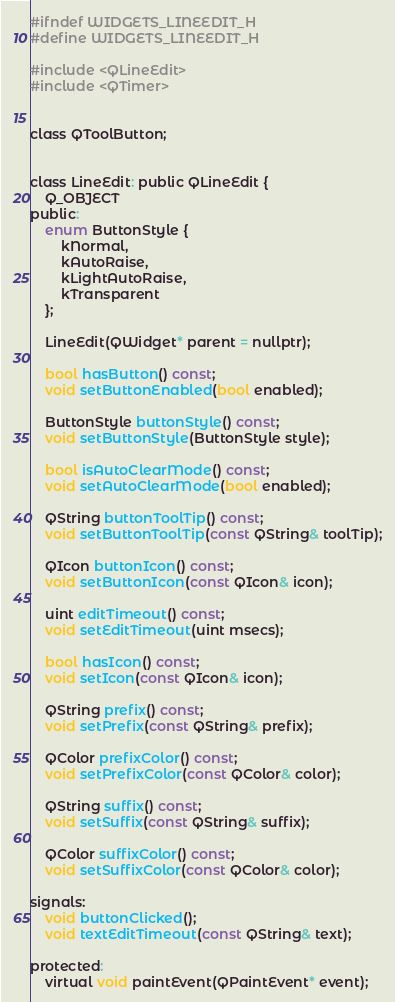Convert code to text. <code><loc_0><loc_0><loc_500><loc_500><_C_>#ifndef WIDGETS_LINEEDIT_H
#define WIDGETS_LINEEDIT_H

#include <QLineEdit>
#include <QTimer>


class QToolButton;


class LineEdit: public QLineEdit {
	Q_OBJECT
public:
	enum ButtonStyle {
		kNormal,
		kAutoRaise,
		kLightAutoRaise,
		kTransparent
	};

	LineEdit(QWidget* parent = nullptr);

	bool hasButton() const;
	void setButtonEnabled(bool enabled);

	ButtonStyle buttonStyle() const;
	void setButtonStyle(ButtonStyle style);

	bool isAutoClearMode() const;
	void setAutoClearMode(bool enabled);

	QString buttonToolTip() const;
	void setButtonToolTip(const QString& toolTip);

	QIcon buttonIcon() const;
	void setButtonIcon(const QIcon& icon);

	uint editTimeout() const;
	void setEditTimeout(uint msecs);

	bool hasIcon() const;
	void setIcon(const QIcon& icon);

	QString prefix() const;
	void setPrefix(const QString& prefix);

	QColor prefixColor() const;
	void setPrefixColor(const QColor& color);

	QString suffix() const;
	void setSuffix(const QString& suffix);

	QColor suffixColor() const;
	void setSuffixColor(const QColor& color);

signals:
	void buttonClicked();
	void textEditTimeout(const QString& text);

protected:
	virtual void paintEvent(QPaintEvent* event);</code> 